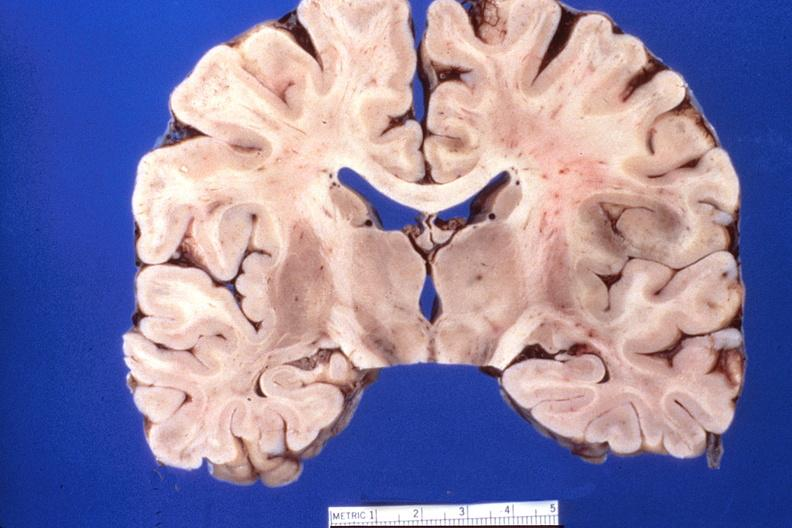s nervous present?
Answer the question using a single word or phrase. Yes 